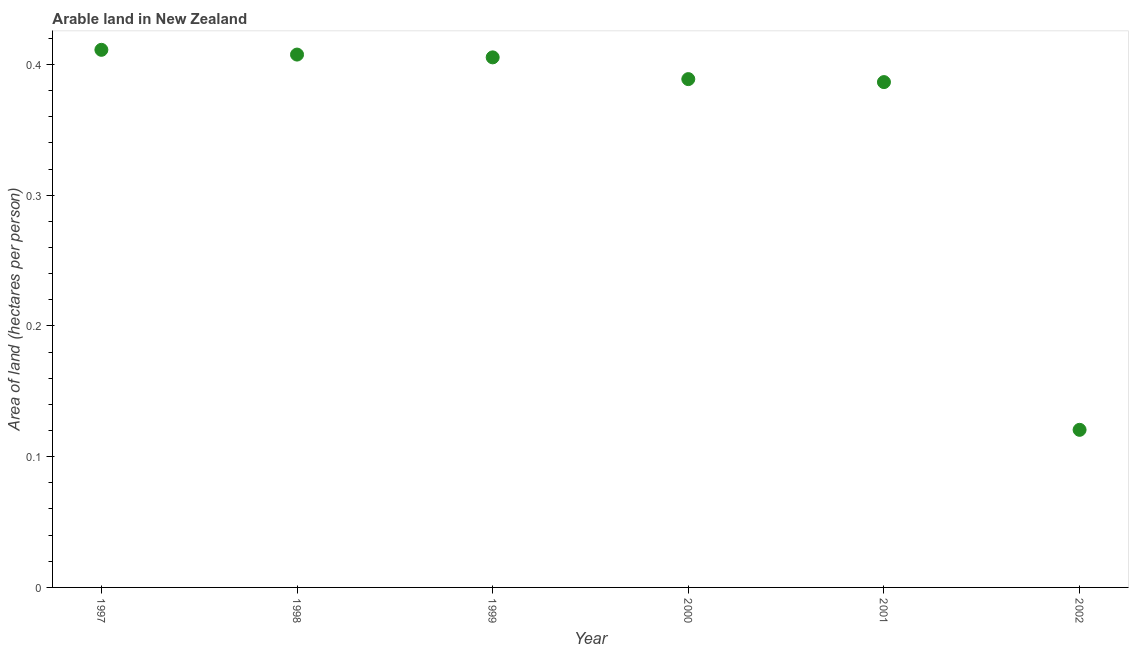What is the area of arable land in 2002?
Keep it short and to the point. 0.12. Across all years, what is the maximum area of arable land?
Your response must be concise. 0.41. Across all years, what is the minimum area of arable land?
Your answer should be compact. 0.12. In which year was the area of arable land minimum?
Your response must be concise. 2002. What is the sum of the area of arable land?
Provide a short and direct response. 2.12. What is the difference between the area of arable land in 1998 and 2002?
Provide a short and direct response. 0.29. What is the average area of arable land per year?
Your answer should be compact. 0.35. What is the median area of arable land?
Offer a terse response. 0.4. In how many years, is the area of arable land greater than 0.04 hectares per person?
Give a very brief answer. 6. What is the ratio of the area of arable land in 1999 to that in 2002?
Your answer should be very brief. 3.36. What is the difference between the highest and the second highest area of arable land?
Give a very brief answer. 0. Is the sum of the area of arable land in 1998 and 2000 greater than the maximum area of arable land across all years?
Ensure brevity in your answer.  Yes. What is the difference between the highest and the lowest area of arable land?
Keep it short and to the point. 0.29. Does the area of arable land monotonically increase over the years?
Provide a succinct answer. No. How many dotlines are there?
Your answer should be compact. 1. What is the difference between two consecutive major ticks on the Y-axis?
Provide a short and direct response. 0.1. What is the title of the graph?
Your answer should be very brief. Arable land in New Zealand. What is the label or title of the Y-axis?
Offer a very short reply. Area of land (hectares per person). What is the Area of land (hectares per person) in 1997?
Offer a very short reply. 0.41. What is the Area of land (hectares per person) in 1998?
Your answer should be very brief. 0.41. What is the Area of land (hectares per person) in 1999?
Your answer should be compact. 0.41. What is the Area of land (hectares per person) in 2000?
Provide a short and direct response. 0.39. What is the Area of land (hectares per person) in 2001?
Keep it short and to the point. 0.39. What is the Area of land (hectares per person) in 2002?
Offer a very short reply. 0.12. What is the difference between the Area of land (hectares per person) in 1997 and 1998?
Give a very brief answer. 0. What is the difference between the Area of land (hectares per person) in 1997 and 1999?
Offer a very short reply. 0.01. What is the difference between the Area of land (hectares per person) in 1997 and 2000?
Keep it short and to the point. 0.02. What is the difference between the Area of land (hectares per person) in 1997 and 2001?
Offer a terse response. 0.02. What is the difference between the Area of land (hectares per person) in 1997 and 2002?
Provide a succinct answer. 0.29. What is the difference between the Area of land (hectares per person) in 1998 and 1999?
Give a very brief answer. 0. What is the difference between the Area of land (hectares per person) in 1998 and 2000?
Ensure brevity in your answer.  0.02. What is the difference between the Area of land (hectares per person) in 1998 and 2001?
Provide a short and direct response. 0.02. What is the difference between the Area of land (hectares per person) in 1998 and 2002?
Your response must be concise. 0.29. What is the difference between the Area of land (hectares per person) in 1999 and 2000?
Give a very brief answer. 0.02. What is the difference between the Area of land (hectares per person) in 1999 and 2001?
Provide a succinct answer. 0.02. What is the difference between the Area of land (hectares per person) in 1999 and 2002?
Your response must be concise. 0.28. What is the difference between the Area of land (hectares per person) in 2000 and 2001?
Your answer should be compact. 0. What is the difference between the Area of land (hectares per person) in 2000 and 2002?
Provide a short and direct response. 0.27. What is the difference between the Area of land (hectares per person) in 2001 and 2002?
Ensure brevity in your answer.  0.27. What is the ratio of the Area of land (hectares per person) in 1997 to that in 1998?
Offer a terse response. 1.01. What is the ratio of the Area of land (hectares per person) in 1997 to that in 2000?
Offer a very short reply. 1.06. What is the ratio of the Area of land (hectares per person) in 1997 to that in 2001?
Offer a very short reply. 1.06. What is the ratio of the Area of land (hectares per person) in 1997 to that in 2002?
Your answer should be very brief. 3.41. What is the ratio of the Area of land (hectares per person) in 1998 to that in 2000?
Provide a succinct answer. 1.05. What is the ratio of the Area of land (hectares per person) in 1998 to that in 2001?
Offer a very short reply. 1.05. What is the ratio of the Area of land (hectares per person) in 1998 to that in 2002?
Your answer should be compact. 3.38. What is the ratio of the Area of land (hectares per person) in 1999 to that in 2000?
Give a very brief answer. 1.04. What is the ratio of the Area of land (hectares per person) in 1999 to that in 2001?
Your answer should be compact. 1.05. What is the ratio of the Area of land (hectares per person) in 1999 to that in 2002?
Provide a succinct answer. 3.36. What is the ratio of the Area of land (hectares per person) in 2000 to that in 2001?
Offer a very short reply. 1.01. What is the ratio of the Area of land (hectares per person) in 2000 to that in 2002?
Keep it short and to the point. 3.23. What is the ratio of the Area of land (hectares per person) in 2001 to that in 2002?
Your response must be concise. 3.21. 